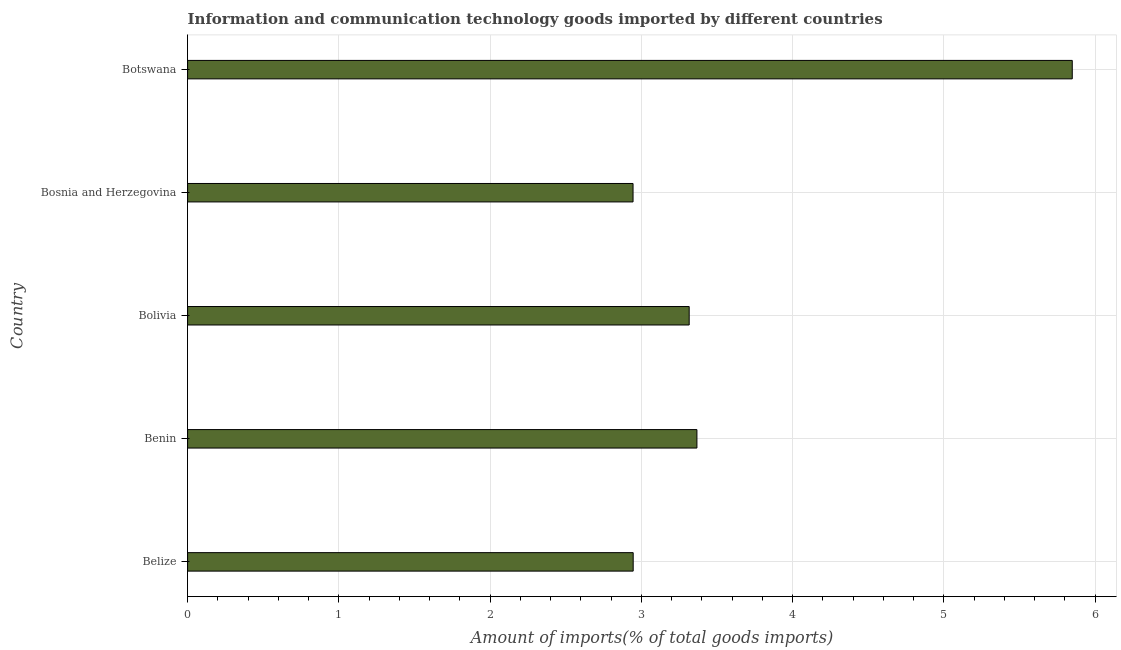Does the graph contain any zero values?
Offer a very short reply. No. Does the graph contain grids?
Keep it short and to the point. Yes. What is the title of the graph?
Your response must be concise. Information and communication technology goods imported by different countries. What is the label or title of the X-axis?
Your response must be concise. Amount of imports(% of total goods imports). What is the amount of ict goods imports in Botswana?
Provide a short and direct response. 5.85. Across all countries, what is the maximum amount of ict goods imports?
Offer a very short reply. 5.85. Across all countries, what is the minimum amount of ict goods imports?
Your answer should be compact. 2.95. In which country was the amount of ict goods imports maximum?
Keep it short and to the point. Botswana. In which country was the amount of ict goods imports minimum?
Keep it short and to the point. Bosnia and Herzegovina. What is the sum of the amount of ict goods imports?
Make the answer very short. 18.42. What is the difference between the amount of ict goods imports in Bolivia and Botswana?
Your answer should be compact. -2.53. What is the average amount of ict goods imports per country?
Offer a terse response. 3.69. What is the median amount of ict goods imports?
Provide a succinct answer. 3.32. Is the amount of ict goods imports in Bolivia less than that in Bosnia and Herzegovina?
Offer a very short reply. No. What is the difference between the highest and the second highest amount of ict goods imports?
Provide a short and direct response. 2.48. Is the sum of the amount of ict goods imports in Benin and Bosnia and Herzegovina greater than the maximum amount of ict goods imports across all countries?
Your answer should be compact. Yes. What is the difference between the highest and the lowest amount of ict goods imports?
Your response must be concise. 2.9. In how many countries, is the amount of ict goods imports greater than the average amount of ict goods imports taken over all countries?
Give a very brief answer. 1. Are all the bars in the graph horizontal?
Your answer should be compact. Yes. What is the difference between two consecutive major ticks on the X-axis?
Offer a terse response. 1. What is the Amount of imports(% of total goods imports) of Belize?
Provide a succinct answer. 2.95. What is the Amount of imports(% of total goods imports) in Benin?
Provide a short and direct response. 3.37. What is the Amount of imports(% of total goods imports) in Bolivia?
Offer a terse response. 3.32. What is the Amount of imports(% of total goods imports) of Bosnia and Herzegovina?
Offer a terse response. 2.95. What is the Amount of imports(% of total goods imports) of Botswana?
Your answer should be compact. 5.85. What is the difference between the Amount of imports(% of total goods imports) in Belize and Benin?
Your response must be concise. -0.42. What is the difference between the Amount of imports(% of total goods imports) in Belize and Bolivia?
Your answer should be compact. -0.37. What is the difference between the Amount of imports(% of total goods imports) in Belize and Bosnia and Herzegovina?
Ensure brevity in your answer.  0. What is the difference between the Amount of imports(% of total goods imports) in Belize and Botswana?
Give a very brief answer. -2.9. What is the difference between the Amount of imports(% of total goods imports) in Benin and Bolivia?
Ensure brevity in your answer.  0.05. What is the difference between the Amount of imports(% of total goods imports) in Benin and Bosnia and Herzegovina?
Provide a short and direct response. 0.42. What is the difference between the Amount of imports(% of total goods imports) in Benin and Botswana?
Your response must be concise. -2.48. What is the difference between the Amount of imports(% of total goods imports) in Bolivia and Bosnia and Herzegovina?
Provide a succinct answer. 0.37. What is the difference between the Amount of imports(% of total goods imports) in Bolivia and Botswana?
Offer a terse response. -2.53. What is the difference between the Amount of imports(% of total goods imports) in Bosnia and Herzegovina and Botswana?
Ensure brevity in your answer.  -2.9. What is the ratio of the Amount of imports(% of total goods imports) in Belize to that in Benin?
Your answer should be very brief. 0.88. What is the ratio of the Amount of imports(% of total goods imports) in Belize to that in Bolivia?
Your response must be concise. 0.89. What is the ratio of the Amount of imports(% of total goods imports) in Belize to that in Bosnia and Herzegovina?
Your answer should be compact. 1. What is the ratio of the Amount of imports(% of total goods imports) in Belize to that in Botswana?
Provide a short and direct response. 0.5. What is the ratio of the Amount of imports(% of total goods imports) in Benin to that in Bosnia and Herzegovina?
Provide a short and direct response. 1.14. What is the ratio of the Amount of imports(% of total goods imports) in Benin to that in Botswana?
Offer a terse response. 0.58. What is the ratio of the Amount of imports(% of total goods imports) in Bolivia to that in Bosnia and Herzegovina?
Offer a terse response. 1.13. What is the ratio of the Amount of imports(% of total goods imports) in Bolivia to that in Botswana?
Offer a very short reply. 0.57. What is the ratio of the Amount of imports(% of total goods imports) in Bosnia and Herzegovina to that in Botswana?
Offer a very short reply. 0.5. 